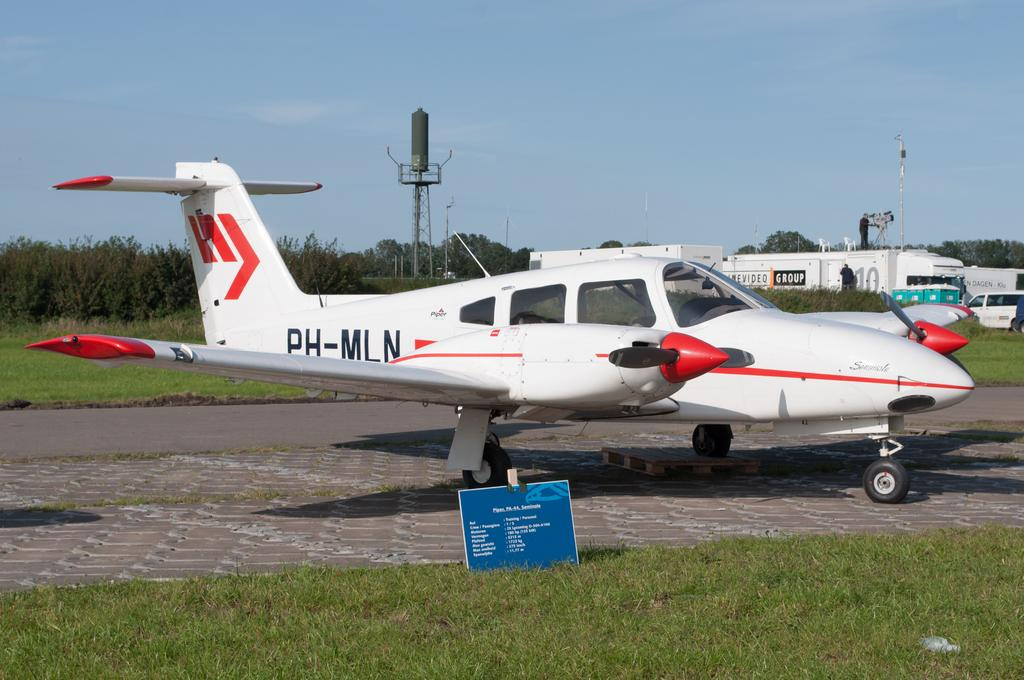What color is the airplane in the image? The airplane in the image is white. What type of natural environment is visible in the image? There is grass and trees in the image. What other vehicles can be seen in the image besides the airplane? There are other vehicles in the image. Where can the icicle be found in the image? There is no icicle present in the image. What type of flame is visible in the image? There is no flame present in the image. 